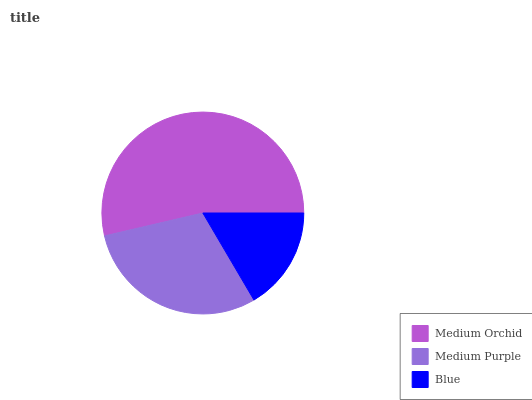Is Blue the minimum?
Answer yes or no. Yes. Is Medium Orchid the maximum?
Answer yes or no. Yes. Is Medium Purple the minimum?
Answer yes or no. No. Is Medium Purple the maximum?
Answer yes or no. No. Is Medium Orchid greater than Medium Purple?
Answer yes or no. Yes. Is Medium Purple less than Medium Orchid?
Answer yes or no. Yes. Is Medium Purple greater than Medium Orchid?
Answer yes or no. No. Is Medium Orchid less than Medium Purple?
Answer yes or no. No. Is Medium Purple the high median?
Answer yes or no. Yes. Is Medium Purple the low median?
Answer yes or no. Yes. Is Medium Orchid the high median?
Answer yes or no. No. Is Blue the low median?
Answer yes or no. No. 